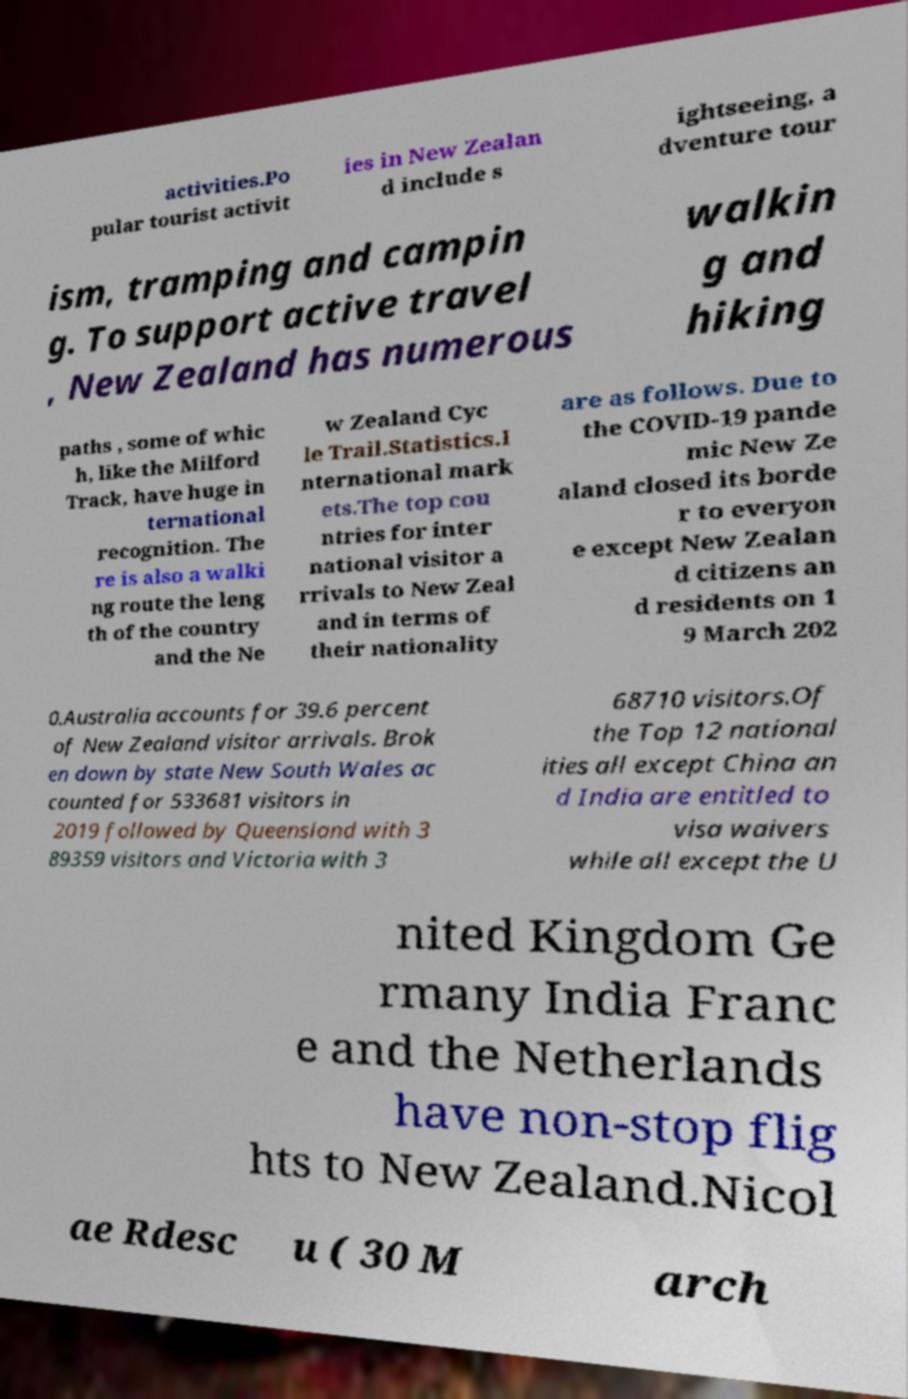What messages or text are displayed in this image? I need them in a readable, typed format. activities.Po pular tourist activit ies in New Zealan d include s ightseeing, a dventure tour ism, tramping and campin g. To support active travel , New Zealand has numerous walkin g and hiking paths , some of whic h, like the Milford Track, have huge in ternational recognition. The re is also a walki ng route the leng th of the country and the Ne w Zealand Cyc le Trail.Statistics.I nternational mark ets.The top cou ntries for inter national visitor a rrivals to New Zeal and in terms of their nationality are as follows. Due to the COVID-19 pande mic New Ze aland closed its borde r to everyon e except New Zealan d citizens an d residents on 1 9 March 202 0.Australia accounts for 39.6 percent of New Zealand visitor arrivals. Brok en down by state New South Wales ac counted for 533681 visitors in 2019 followed by Queensland with 3 89359 visitors and Victoria with 3 68710 visitors.Of the Top 12 national ities all except China an d India are entitled to visa waivers while all except the U nited Kingdom Ge rmany India Franc e and the Netherlands have non-stop flig hts to New Zealand.Nicol ae Rdesc u ( 30 M arch 